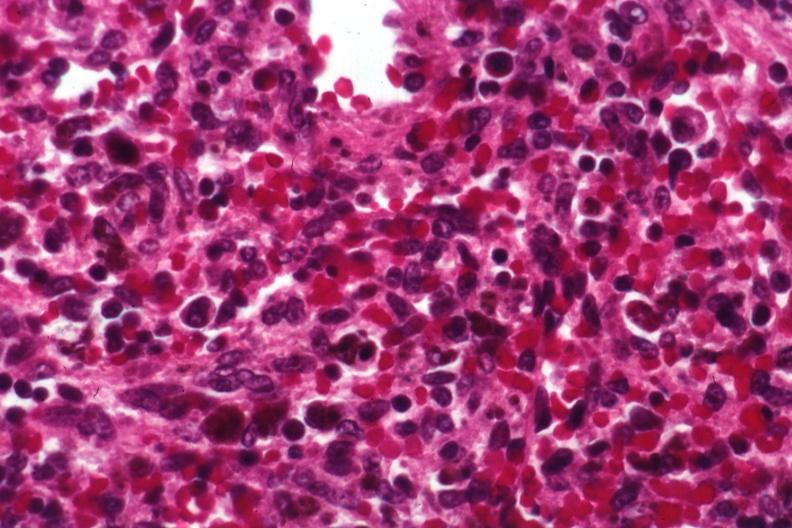what is present?
Answer the question using a single word or phrase. Spleen 